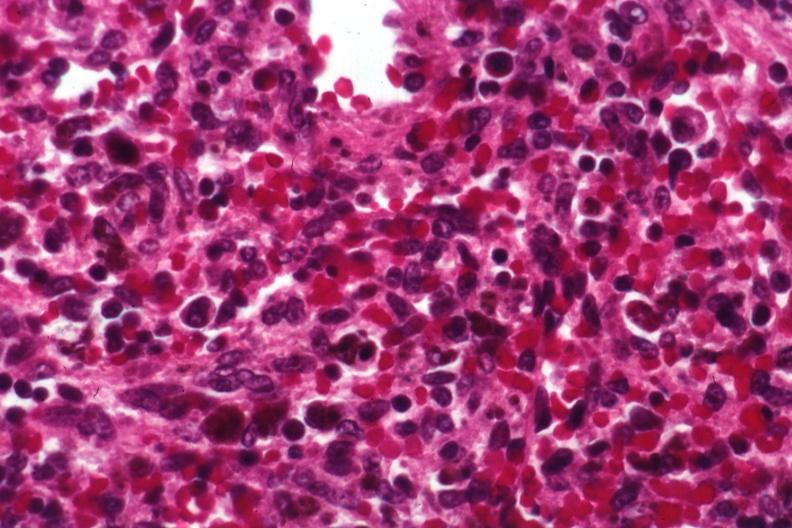what is present?
Answer the question using a single word or phrase. Spleen 